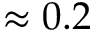Convert formula to latex. <formula><loc_0><loc_0><loc_500><loc_500>\approx 0 . 2</formula> 